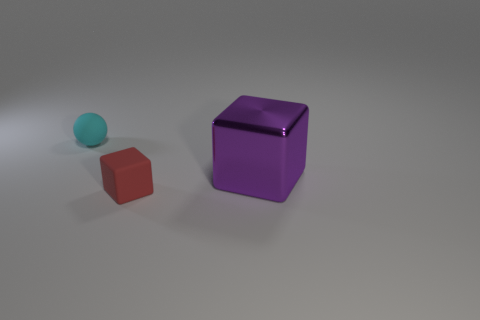Is there anything else that is the same shape as the small cyan thing?
Offer a terse response. No. Are there any other things that have the same size as the purple metallic block?
Offer a terse response. No. How many matte things are tiny blue blocks or purple blocks?
Your answer should be very brief. 0. The cyan rubber ball has what size?
Provide a succinct answer. Small. Is the rubber ball the same size as the matte block?
Your response must be concise. Yes. There is a small thing that is behind the tiny matte block; what is it made of?
Your response must be concise. Rubber. There is another object that is the same shape as the large thing; what material is it?
Your answer should be very brief. Rubber. Are there any things that are in front of the tiny thing behind the big purple cube?
Give a very brief answer. Yes. Is the shape of the small red rubber object the same as the large purple metal thing?
Provide a succinct answer. Yes. What is the shape of the cyan object that is made of the same material as the red block?
Offer a terse response. Sphere. 